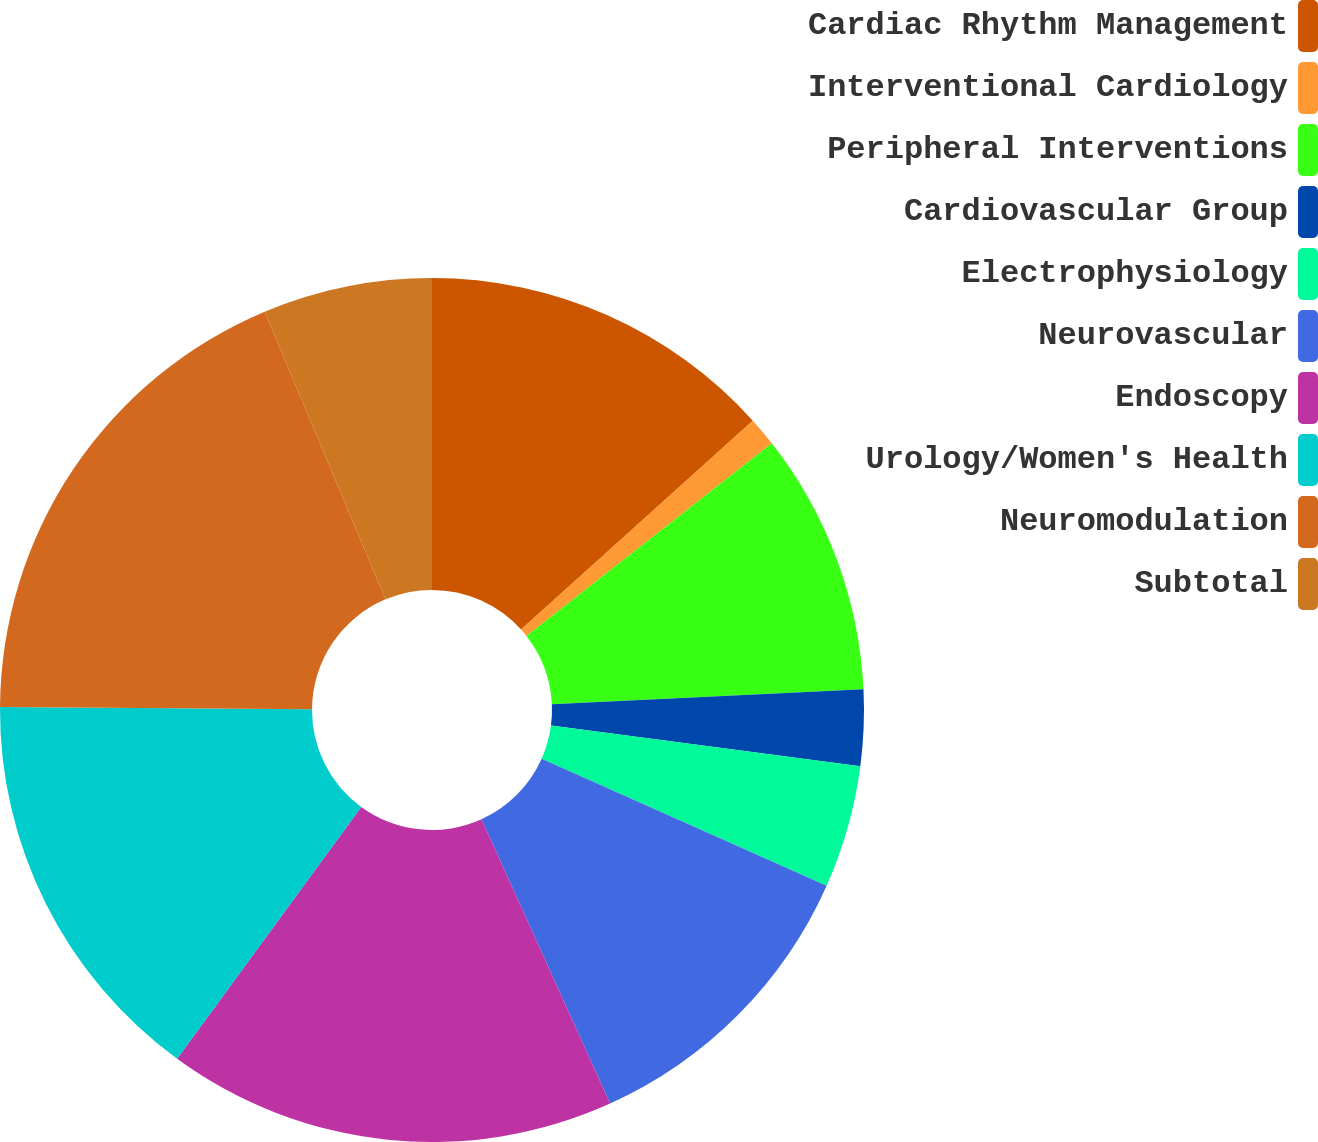Convert chart to OTSL. <chart><loc_0><loc_0><loc_500><loc_500><pie_chart><fcel>Cardiac Rhythm Management<fcel>Interventional Cardiology<fcel>Peripheral Interventions<fcel>Cardiovascular Group<fcel>Electrophysiology<fcel>Neurovascular<fcel>Endoscopy<fcel>Urology/Women's Health<fcel>Neuromodulation<fcel>Subtotal<nl><fcel>13.32%<fcel>1.09%<fcel>9.83%<fcel>2.84%<fcel>4.59%<fcel>11.57%<fcel>16.81%<fcel>15.07%<fcel>18.56%<fcel>6.33%<nl></chart> 